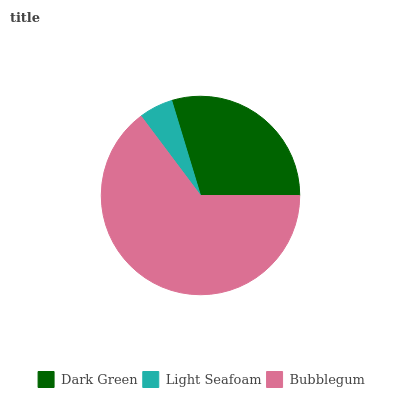Is Light Seafoam the minimum?
Answer yes or no. Yes. Is Bubblegum the maximum?
Answer yes or no. Yes. Is Bubblegum the minimum?
Answer yes or no. No. Is Light Seafoam the maximum?
Answer yes or no. No. Is Bubblegum greater than Light Seafoam?
Answer yes or no. Yes. Is Light Seafoam less than Bubblegum?
Answer yes or no. Yes. Is Light Seafoam greater than Bubblegum?
Answer yes or no. No. Is Bubblegum less than Light Seafoam?
Answer yes or no. No. Is Dark Green the high median?
Answer yes or no. Yes. Is Dark Green the low median?
Answer yes or no. Yes. Is Light Seafoam the high median?
Answer yes or no. No. Is Bubblegum the low median?
Answer yes or no. No. 